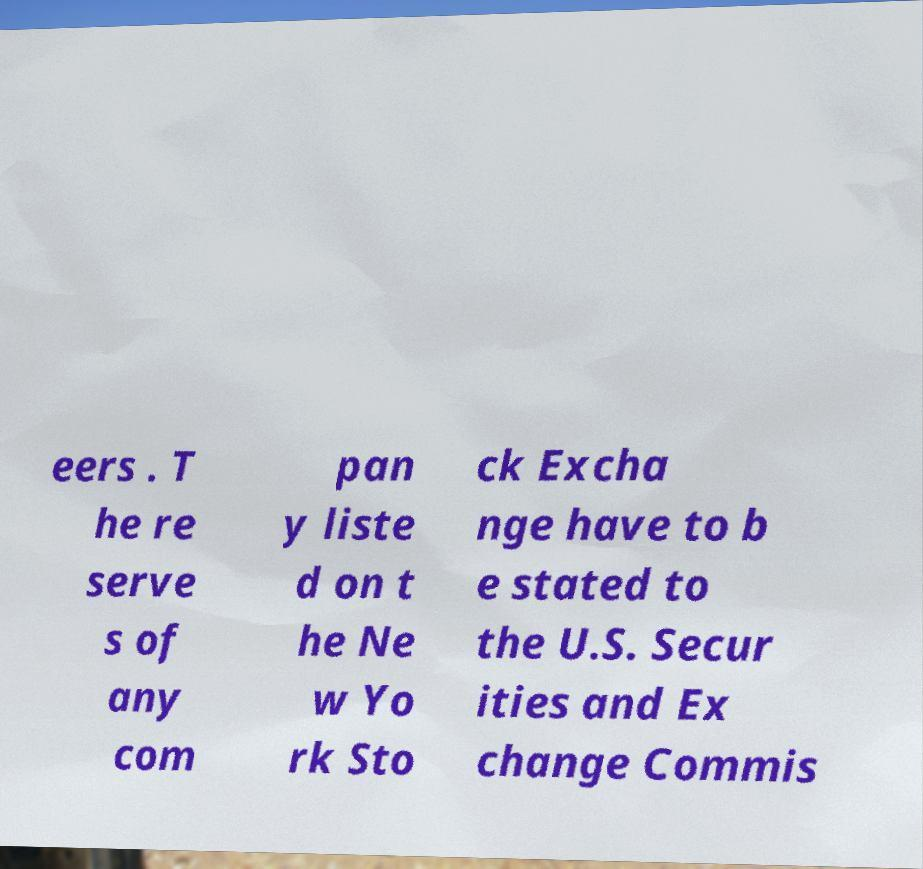Please read and relay the text visible in this image. What does it say? eers . T he re serve s of any com pan y liste d on t he Ne w Yo rk Sto ck Excha nge have to b e stated to the U.S. Secur ities and Ex change Commis 